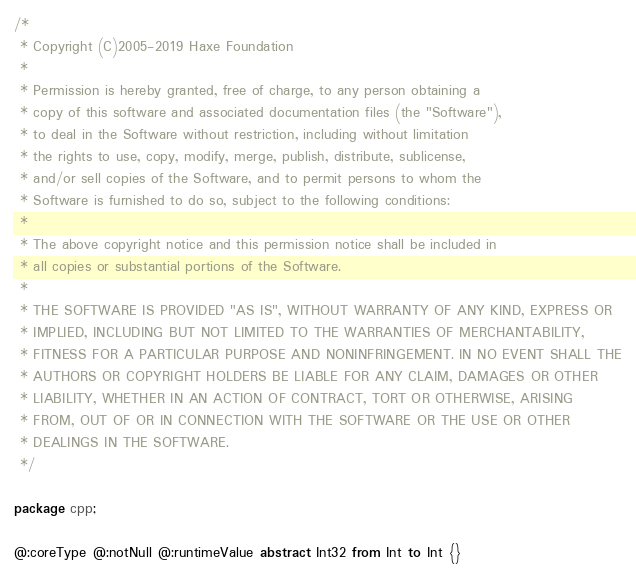Convert code to text. <code><loc_0><loc_0><loc_500><loc_500><_Haxe_>/*
 * Copyright (C)2005-2019 Haxe Foundation
 *
 * Permission is hereby granted, free of charge, to any person obtaining a
 * copy of this software and associated documentation files (the "Software"),
 * to deal in the Software without restriction, including without limitation
 * the rights to use, copy, modify, merge, publish, distribute, sublicense,
 * and/or sell copies of the Software, and to permit persons to whom the
 * Software is furnished to do so, subject to the following conditions:
 *
 * The above copyright notice and this permission notice shall be included in
 * all copies or substantial portions of the Software.
 *
 * THE SOFTWARE IS PROVIDED "AS IS", WITHOUT WARRANTY OF ANY KIND, EXPRESS OR
 * IMPLIED, INCLUDING BUT NOT LIMITED TO THE WARRANTIES OF MERCHANTABILITY,
 * FITNESS FOR A PARTICULAR PURPOSE AND NONINFRINGEMENT. IN NO EVENT SHALL THE
 * AUTHORS OR COPYRIGHT HOLDERS BE LIABLE FOR ANY CLAIM, DAMAGES OR OTHER
 * LIABILITY, WHETHER IN AN ACTION OF CONTRACT, TORT OR OTHERWISE, ARISING
 * FROM, OUT OF OR IN CONNECTION WITH THE SOFTWARE OR THE USE OR OTHER
 * DEALINGS IN THE SOFTWARE.
 */

package cpp;

@:coreType @:notNull @:runtimeValue abstract Int32 from Int to Int {}
</code> 